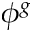<formula> <loc_0><loc_0><loc_500><loc_500>\phi ^ { g }</formula> 